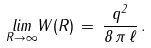<formula> <loc_0><loc_0><loc_500><loc_500>\underset { R \to \infty } { l i m } W ( R ) \, = \, \frac { q ^ { 2 } } { 8 \, \pi \, \ell } \, .</formula> 